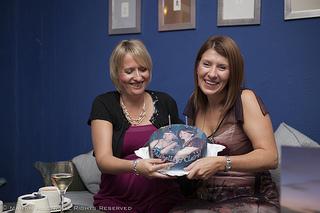What is the woman doing to the cake?
Write a very short answer. Holding it. What kind of cake is that?
Quick response, please. Birthday. Is this a birthday cake?
Answer briefly. Yes. What is the woman eating?
Give a very brief answer. Cake. What color is the wall?
Write a very short answer. Blue. What is the design on the cake?
Quick response, please. Picture. What is the woman about to do?
Short answer required. Eat cake. Is the women's picture on the cake?
Quick response, please. Yes. 